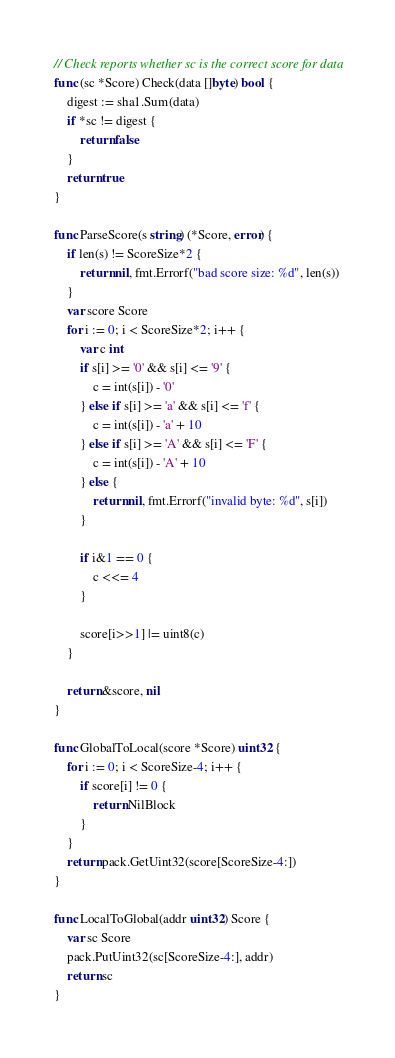Convert code to text. <code><loc_0><loc_0><loc_500><loc_500><_Go_>// Check reports whether sc is the correct score for data
func (sc *Score) Check(data []byte) bool {
	digest := sha1.Sum(data)
	if *sc != digest {
		return false
	}
	return true
}

func ParseScore(s string) (*Score, error) {
	if len(s) != ScoreSize*2 {
		return nil, fmt.Errorf("bad score size: %d", len(s))
	}
	var score Score
	for i := 0; i < ScoreSize*2; i++ {
		var c int
		if s[i] >= '0' && s[i] <= '9' {
			c = int(s[i]) - '0'
		} else if s[i] >= 'a' && s[i] <= 'f' {
			c = int(s[i]) - 'a' + 10
		} else if s[i] >= 'A' && s[i] <= 'F' {
			c = int(s[i]) - 'A' + 10
		} else {
			return nil, fmt.Errorf("invalid byte: %d", s[i])
		}

		if i&1 == 0 {
			c <<= 4
		}

		score[i>>1] |= uint8(c)
	}

	return &score, nil
}

func GlobalToLocal(score *Score) uint32 {
	for i := 0; i < ScoreSize-4; i++ {
		if score[i] != 0 {
			return NilBlock
		}
	}
	return pack.GetUint32(score[ScoreSize-4:])
}

func LocalToGlobal(addr uint32) Score {
	var sc Score
	pack.PutUint32(sc[ScoreSize-4:], addr)
	return sc
}
</code> 